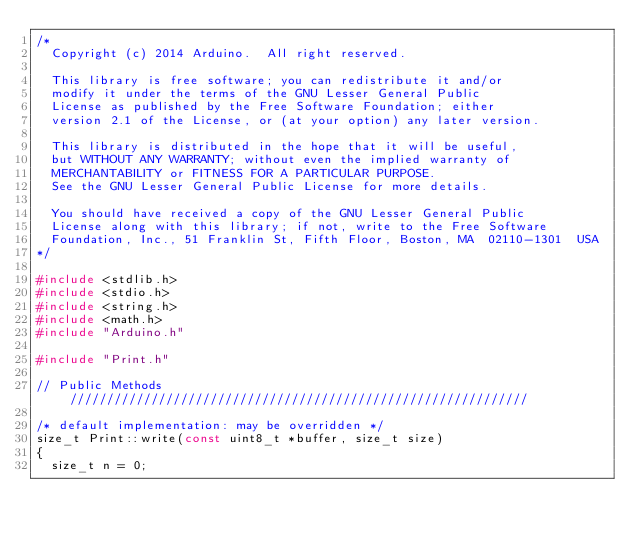Convert code to text. <code><loc_0><loc_0><loc_500><loc_500><_C++_>/*
  Copyright (c) 2014 Arduino.  All right reserved.

  This library is free software; you can redistribute it and/or
  modify it under the terms of the GNU Lesser General Public
  License as published by the Free Software Foundation; either
  version 2.1 of the License, or (at your option) any later version.

  This library is distributed in the hope that it will be useful,
  but WITHOUT ANY WARRANTY; without even the implied warranty of
  MERCHANTABILITY or FITNESS FOR A PARTICULAR PURPOSE.
  See the GNU Lesser General Public License for more details.

  You should have received a copy of the GNU Lesser General Public
  License along with this library; if not, write to the Free Software
  Foundation, Inc., 51 Franklin St, Fifth Floor, Boston, MA  02110-1301  USA
*/

#include <stdlib.h>
#include <stdio.h>
#include <string.h>
#include <math.h>
#include "Arduino.h"

#include "Print.h"

// Public Methods //////////////////////////////////////////////////////////////

/* default implementation: may be overridden */
size_t Print::write(const uint8_t *buffer, size_t size)
{
  size_t n = 0;</code> 